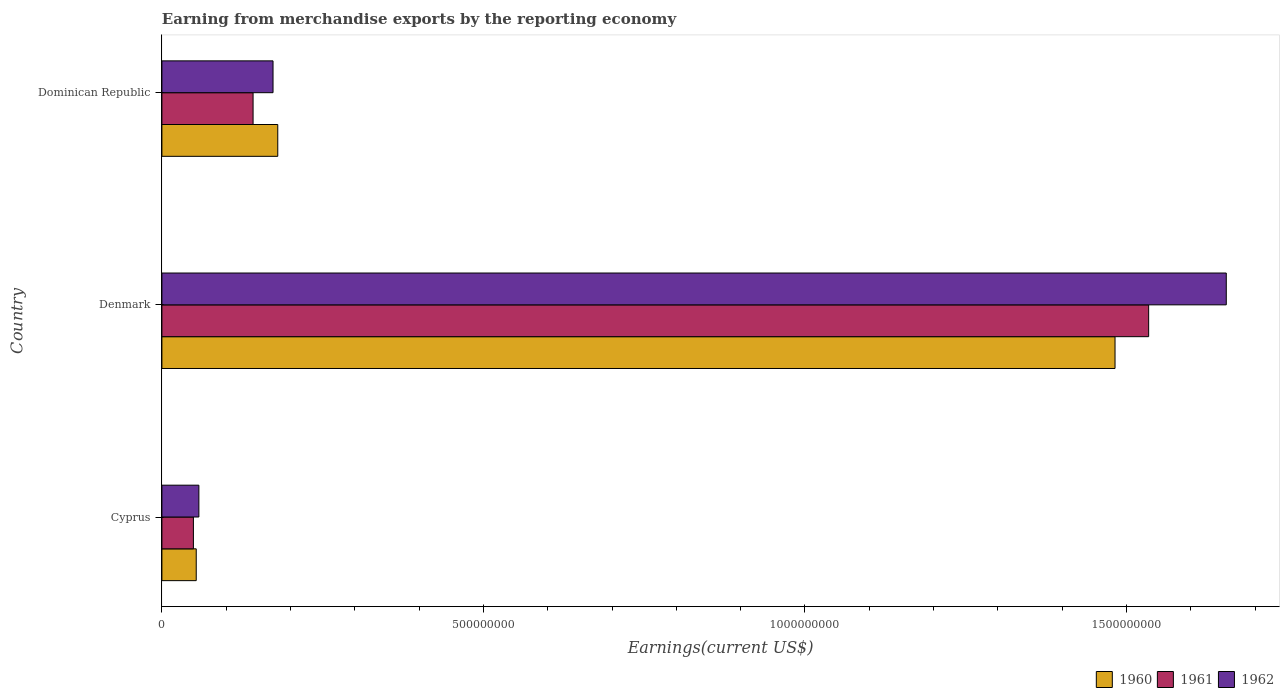How many different coloured bars are there?
Your answer should be very brief. 3. How many groups of bars are there?
Your response must be concise. 3. Are the number of bars per tick equal to the number of legend labels?
Make the answer very short. Yes. Are the number of bars on each tick of the Y-axis equal?
Your answer should be very brief. Yes. What is the label of the 1st group of bars from the top?
Provide a succinct answer. Dominican Republic. What is the amount earned from merchandise exports in 1961 in Cyprus?
Your answer should be compact. 4.90e+07. Across all countries, what is the maximum amount earned from merchandise exports in 1962?
Your answer should be compact. 1.66e+09. Across all countries, what is the minimum amount earned from merchandise exports in 1961?
Make the answer very short. 4.90e+07. In which country was the amount earned from merchandise exports in 1961 minimum?
Offer a very short reply. Cyprus. What is the total amount earned from merchandise exports in 1962 in the graph?
Offer a terse response. 1.89e+09. What is the difference between the amount earned from merchandise exports in 1962 in Denmark and that in Dominican Republic?
Make the answer very short. 1.48e+09. What is the difference between the amount earned from merchandise exports in 1960 in Denmark and the amount earned from merchandise exports in 1962 in Dominican Republic?
Provide a succinct answer. 1.31e+09. What is the average amount earned from merchandise exports in 1961 per country?
Offer a terse response. 5.75e+08. What is the difference between the amount earned from merchandise exports in 1961 and amount earned from merchandise exports in 1960 in Dominican Republic?
Offer a terse response. -3.84e+07. What is the ratio of the amount earned from merchandise exports in 1962 in Cyprus to that in Dominican Republic?
Ensure brevity in your answer.  0.33. Is the amount earned from merchandise exports in 1961 in Cyprus less than that in Denmark?
Your answer should be very brief. Yes. Is the difference between the amount earned from merchandise exports in 1961 in Denmark and Dominican Republic greater than the difference between the amount earned from merchandise exports in 1960 in Denmark and Dominican Republic?
Make the answer very short. Yes. What is the difference between the highest and the second highest amount earned from merchandise exports in 1960?
Make the answer very short. 1.30e+09. What is the difference between the highest and the lowest amount earned from merchandise exports in 1962?
Your answer should be very brief. 1.60e+09. In how many countries, is the amount earned from merchandise exports in 1961 greater than the average amount earned from merchandise exports in 1961 taken over all countries?
Make the answer very short. 1. Is the sum of the amount earned from merchandise exports in 1962 in Denmark and Dominican Republic greater than the maximum amount earned from merchandise exports in 1960 across all countries?
Provide a succinct answer. Yes. Are the values on the major ticks of X-axis written in scientific E-notation?
Provide a short and direct response. No. Does the graph contain grids?
Ensure brevity in your answer.  No. How many legend labels are there?
Make the answer very short. 3. How are the legend labels stacked?
Your response must be concise. Horizontal. What is the title of the graph?
Offer a very short reply. Earning from merchandise exports by the reporting economy. What is the label or title of the X-axis?
Keep it short and to the point. Earnings(current US$). What is the label or title of the Y-axis?
Give a very brief answer. Country. What is the Earnings(current US$) of 1960 in Cyprus?
Your response must be concise. 5.34e+07. What is the Earnings(current US$) in 1961 in Cyprus?
Offer a terse response. 4.90e+07. What is the Earnings(current US$) of 1962 in Cyprus?
Give a very brief answer. 5.75e+07. What is the Earnings(current US$) in 1960 in Denmark?
Your answer should be compact. 1.48e+09. What is the Earnings(current US$) in 1961 in Denmark?
Your response must be concise. 1.53e+09. What is the Earnings(current US$) of 1962 in Denmark?
Keep it short and to the point. 1.66e+09. What is the Earnings(current US$) of 1960 in Dominican Republic?
Offer a very short reply. 1.80e+08. What is the Earnings(current US$) of 1961 in Dominican Republic?
Your answer should be compact. 1.42e+08. What is the Earnings(current US$) of 1962 in Dominican Republic?
Keep it short and to the point. 1.73e+08. Across all countries, what is the maximum Earnings(current US$) in 1960?
Provide a short and direct response. 1.48e+09. Across all countries, what is the maximum Earnings(current US$) of 1961?
Your answer should be very brief. 1.53e+09. Across all countries, what is the maximum Earnings(current US$) of 1962?
Make the answer very short. 1.66e+09. Across all countries, what is the minimum Earnings(current US$) of 1960?
Keep it short and to the point. 5.34e+07. Across all countries, what is the minimum Earnings(current US$) of 1961?
Give a very brief answer. 4.90e+07. Across all countries, what is the minimum Earnings(current US$) of 1962?
Give a very brief answer. 5.75e+07. What is the total Earnings(current US$) in 1960 in the graph?
Give a very brief answer. 1.72e+09. What is the total Earnings(current US$) in 1961 in the graph?
Offer a very short reply. 1.73e+09. What is the total Earnings(current US$) in 1962 in the graph?
Offer a terse response. 1.89e+09. What is the difference between the Earnings(current US$) of 1960 in Cyprus and that in Denmark?
Provide a short and direct response. -1.43e+09. What is the difference between the Earnings(current US$) in 1961 in Cyprus and that in Denmark?
Your answer should be compact. -1.49e+09. What is the difference between the Earnings(current US$) in 1962 in Cyprus and that in Denmark?
Your response must be concise. -1.60e+09. What is the difference between the Earnings(current US$) of 1960 in Cyprus and that in Dominican Republic?
Keep it short and to the point. -1.27e+08. What is the difference between the Earnings(current US$) of 1961 in Cyprus and that in Dominican Republic?
Your answer should be compact. -9.28e+07. What is the difference between the Earnings(current US$) of 1962 in Cyprus and that in Dominican Republic?
Provide a short and direct response. -1.15e+08. What is the difference between the Earnings(current US$) of 1960 in Denmark and that in Dominican Republic?
Offer a very short reply. 1.30e+09. What is the difference between the Earnings(current US$) of 1961 in Denmark and that in Dominican Republic?
Your answer should be compact. 1.39e+09. What is the difference between the Earnings(current US$) of 1962 in Denmark and that in Dominican Republic?
Provide a succinct answer. 1.48e+09. What is the difference between the Earnings(current US$) in 1960 in Cyprus and the Earnings(current US$) in 1961 in Denmark?
Provide a succinct answer. -1.48e+09. What is the difference between the Earnings(current US$) in 1960 in Cyprus and the Earnings(current US$) in 1962 in Denmark?
Offer a very short reply. -1.60e+09. What is the difference between the Earnings(current US$) in 1961 in Cyprus and the Earnings(current US$) in 1962 in Denmark?
Provide a succinct answer. -1.61e+09. What is the difference between the Earnings(current US$) of 1960 in Cyprus and the Earnings(current US$) of 1961 in Dominican Republic?
Ensure brevity in your answer.  -8.84e+07. What is the difference between the Earnings(current US$) of 1960 in Cyprus and the Earnings(current US$) of 1962 in Dominican Republic?
Ensure brevity in your answer.  -1.19e+08. What is the difference between the Earnings(current US$) of 1961 in Cyprus and the Earnings(current US$) of 1962 in Dominican Republic?
Provide a succinct answer. -1.24e+08. What is the difference between the Earnings(current US$) of 1960 in Denmark and the Earnings(current US$) of 1961 in Dominican Republic?
Ensure brevity in your answer.  1.34e+09. What is the difference between the Earnings(current US$) in 1960 in Denmark and the Earnings(current US$) in 1962 in Dominican Republic?
Give a very brief answer. 1.31e+09. What is the difference between the Earnings(current US$) in 1961 in Denmark and the Earnings(current US$) in 1962 in Dominican Republic?
Offer a very short reply. 1.36e+09. What is the average Earnings(current US$) in 1960 per country?
Ensure brevity in your answer.  5.72e+08. What is the average Earnings(current US$) of 1961 per country?
Your response must be concise. 5.75e+08. What is the average Earnings(current US$) in 1962 per country?
Provide a short and direct response. 6.29e+08. What is the difference between the Earnings(current US$) in 1960 and Earnings(current US$) in 1961 in Cyprus?
Provide a short and direct response. 4.40e+06. What is the difference between the Earnings(current US$) in 1960 and Earnings(current US$) in 1962 in Cyprus?
Offer a terse response. -4.10e+06. What is the difference between the Earnings(current US$) of 1961 and Earnings(current US$) of 1962 in Cyprus?
Make the answer very short. -8.50e+06. What is the difference between the Earnings(current US$) of 1960 and Earnings(current US$) of 1961 in Denmark?
Your answer should be compact. -5.23e+07. What is the difference between the Earnings(current US$) of 1960 and Earnings(current US$) of 1962 in Denmark?
Give a very brief answer. -1.73e+08. What is the difference between the Earnings(current US$) of 1961 and Earnings(current US$) of 1962 in Denmark?
Give a very brief answer. -1.21e+08. What is the difference between the Earnings(current US$) of 1960 and Earnings(current US$) of 1961 in Dominican Republic?
Your answer should be very brief. 3.84e+07. What is the difference between the Earnings(current US$) of 1960 and Earnings(current US$) of 1962 in Dominican Republic?
Your answer should be compact. 7.38e+06. What is the difference between the Earnings(current US$) of 1961 and Earnings(current US$) of 1962 in Dominican Republic?
Your answer should be very brief. -3.10e+07. What is the ratio of the Earnings(current US$) in 1960 in Cyprus to that in Denmark?
Provide a succinct answer. 0.04. What is the ratio of the Earnings(current US$) of 1961 in Cyprus to that in Denmark?
Provide a succinct answer. 0.03. What is the ratio of the Earnings(current US$) of 1962 in Cyprus to that in Denmark?
Keep it short and to the point. 0.03. What is the ratio of the Earnings(current US$) in 1960 in Cyprus to that in Dominican Republic?
Offer a very short reply. 0.3. What is the ratio of the Earnings(current US$) in 1961 in Cyprus to that in Dominican Republic?
Keep it short and to the point. 0.35. What is the ratio of the Earnings(current US$) of 1962 in Cyprus to that in Dominican Republic?
Your answer should be very brief. 0.33. What is the ratio of the Earnings(current US$) of 1960 in Denmark to that in Dominican Republic?
Ensure brevity in your answer.  8.23. What is the ratio of the Earnings(current US$) in 1961 in Denmark to that in Dominican Republic?
Your response must be concise. 10.82. What is the ratio of the Earnings(current US$) in 1962 in Denmark to that in Dominican Republic?
Offer a terse response. 9.58. What is the difference between the highest and the second highest Earnings(current US$) of 1960?
Give a very brief answer. 1.30e+09. What is the difference between the highest and the second highest Earnings(current US$) of 1961?
Provide a succinct answer. 1.39e+09. What is the difference between the highest and the second highest Earnings(current US$) of 1962?
Provide a short and direct response. 1.48e+09. What is the difference between the highest and the lowest Earnings(current US$) in 1960?
Give a very brief answer. 1.43e+09. What is the difference between the highest and the lowest Earnings(current US$) of 1961?
Provide a succinct answer. 1.49e+09. What is the difference between the highest and the lowest Earnings(current US$) of 1962?
Your response must be concise. 1.60e+09. 